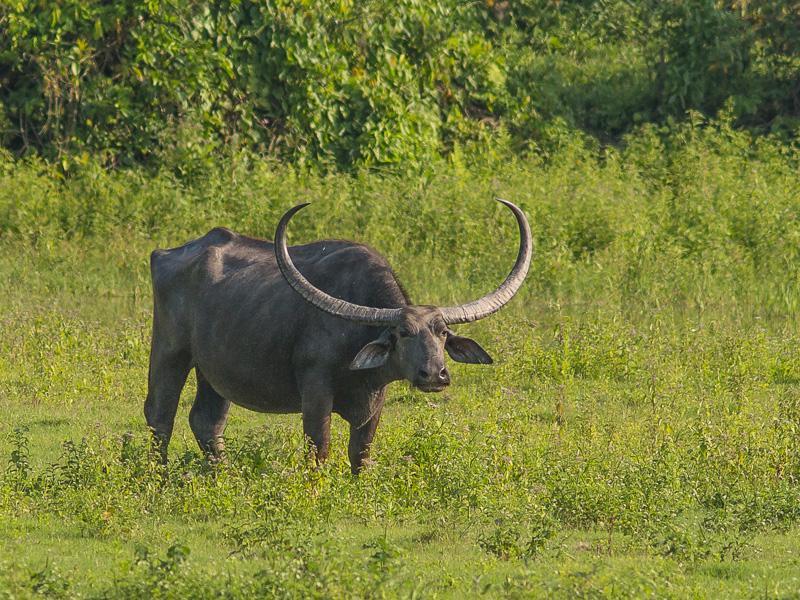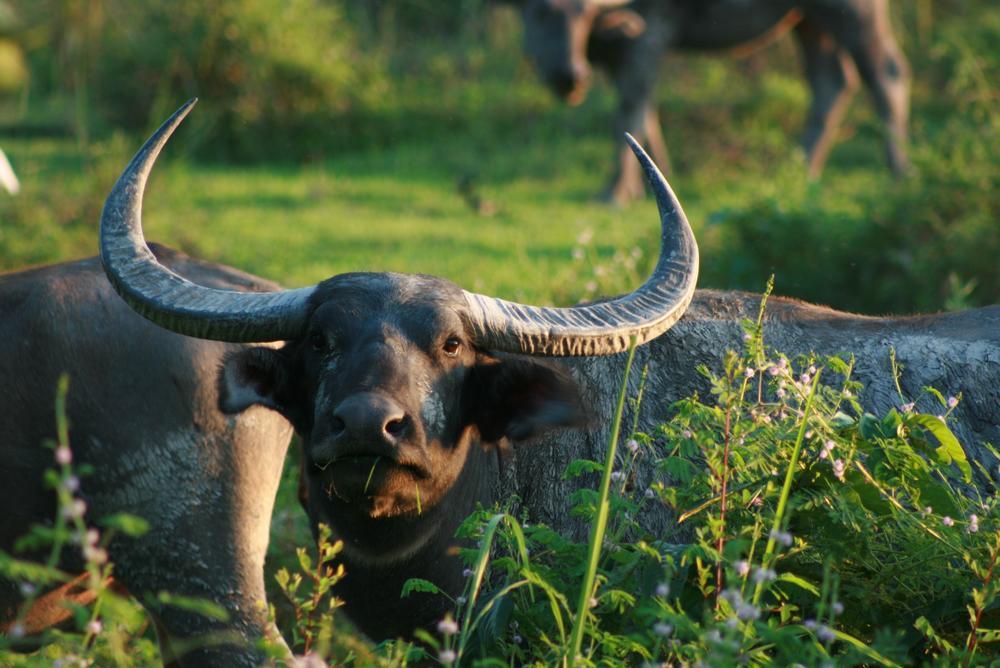The first image is the image on the left, the second image is the image on the right. Considering the images on both sides, is "At least one of the images contains more than one water buffalo." valid? Answer yes or no. Yes. The first image is the image on the left, the second image is the image on the right. Considering the images on both sides, is "Left image contains one dark water buffalo with light coloring on its lower legs, and its head turned to look directly at the camera." valid? Answer yes or no. No. 